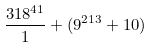<formula> <loc_0><loc_0><loc_500><loc_500>\frac { 3 1 8 ^ { 4 1 } } { 1 } + ( 9 ^ { 2 1 3 } + 1 0 )</formula> 